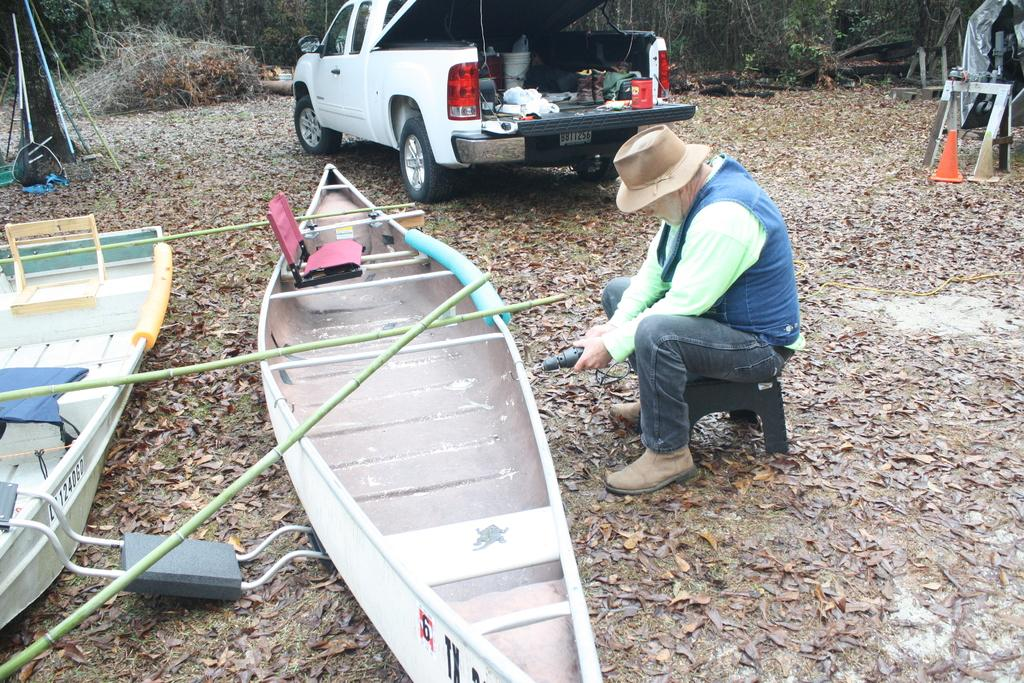What type of vehicles can be seen in the image? There is a vehicle in the image. What objects are present in the image that are used for transportation? There are boats in the image, which are also used for transportation. What type of furniture is in the image? There is a stool in the image. What safety equipment is present in the image? There are traffic cones in the image. What type of plants can be seen in the image? There are trees in the image. What type of headwear is the person in the image wearing? There is a person wearing a cap in the image. What type of footwear is present in the image? There are shoes in the image. What type of natural debris can be seen on the ground in the image? There are dried leaves on the ground in the image. What type of vegetable is being used as a prop in the image? There is no vegetable present in the image. What type of clothing is the person wearing on their lower body in the image? The provided facts do not mention any trousers or lower body clothing for the person in the image. What type of bubble can be seen floating in the image? There is no bubble present in the image. 